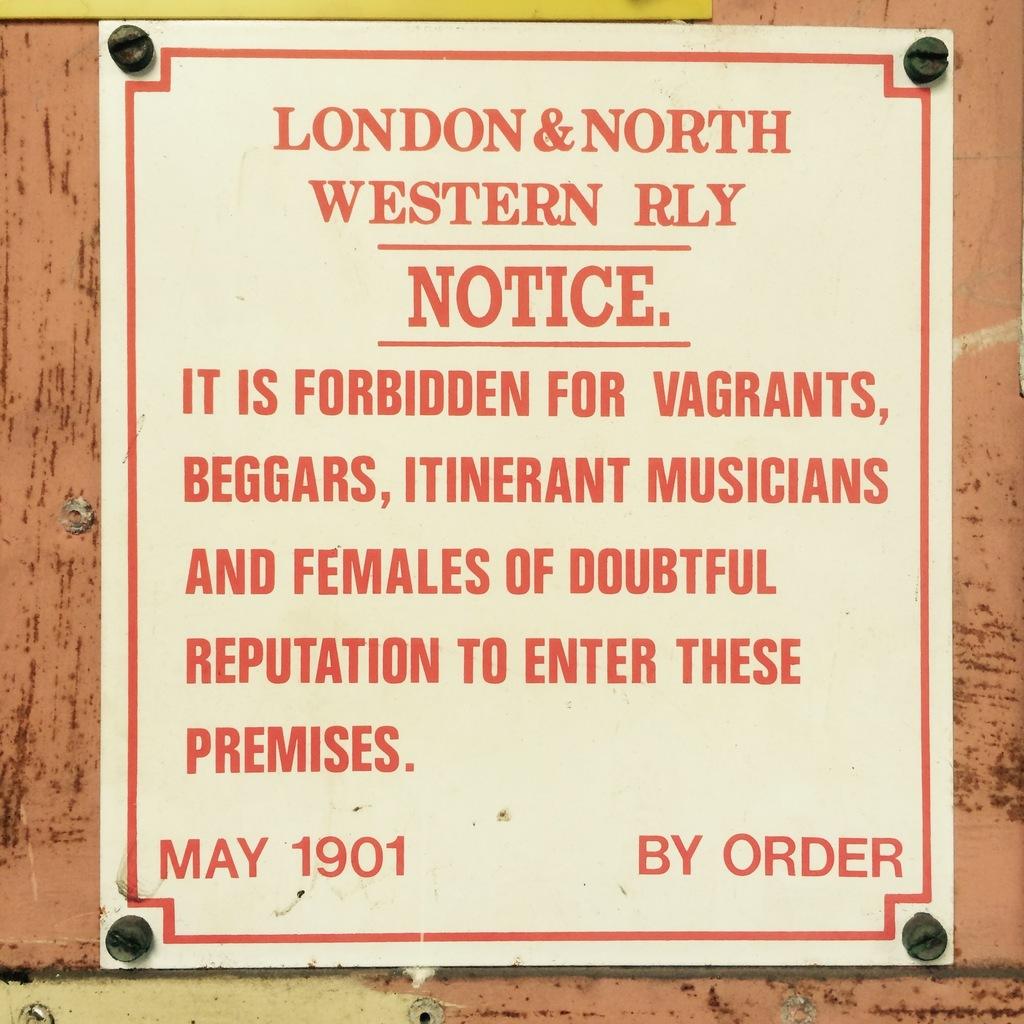What year was the london & north western rly put into order?
Make the answer very short. 1901. Can females of double reputation go in this area?
Give a very brief answer. No. 